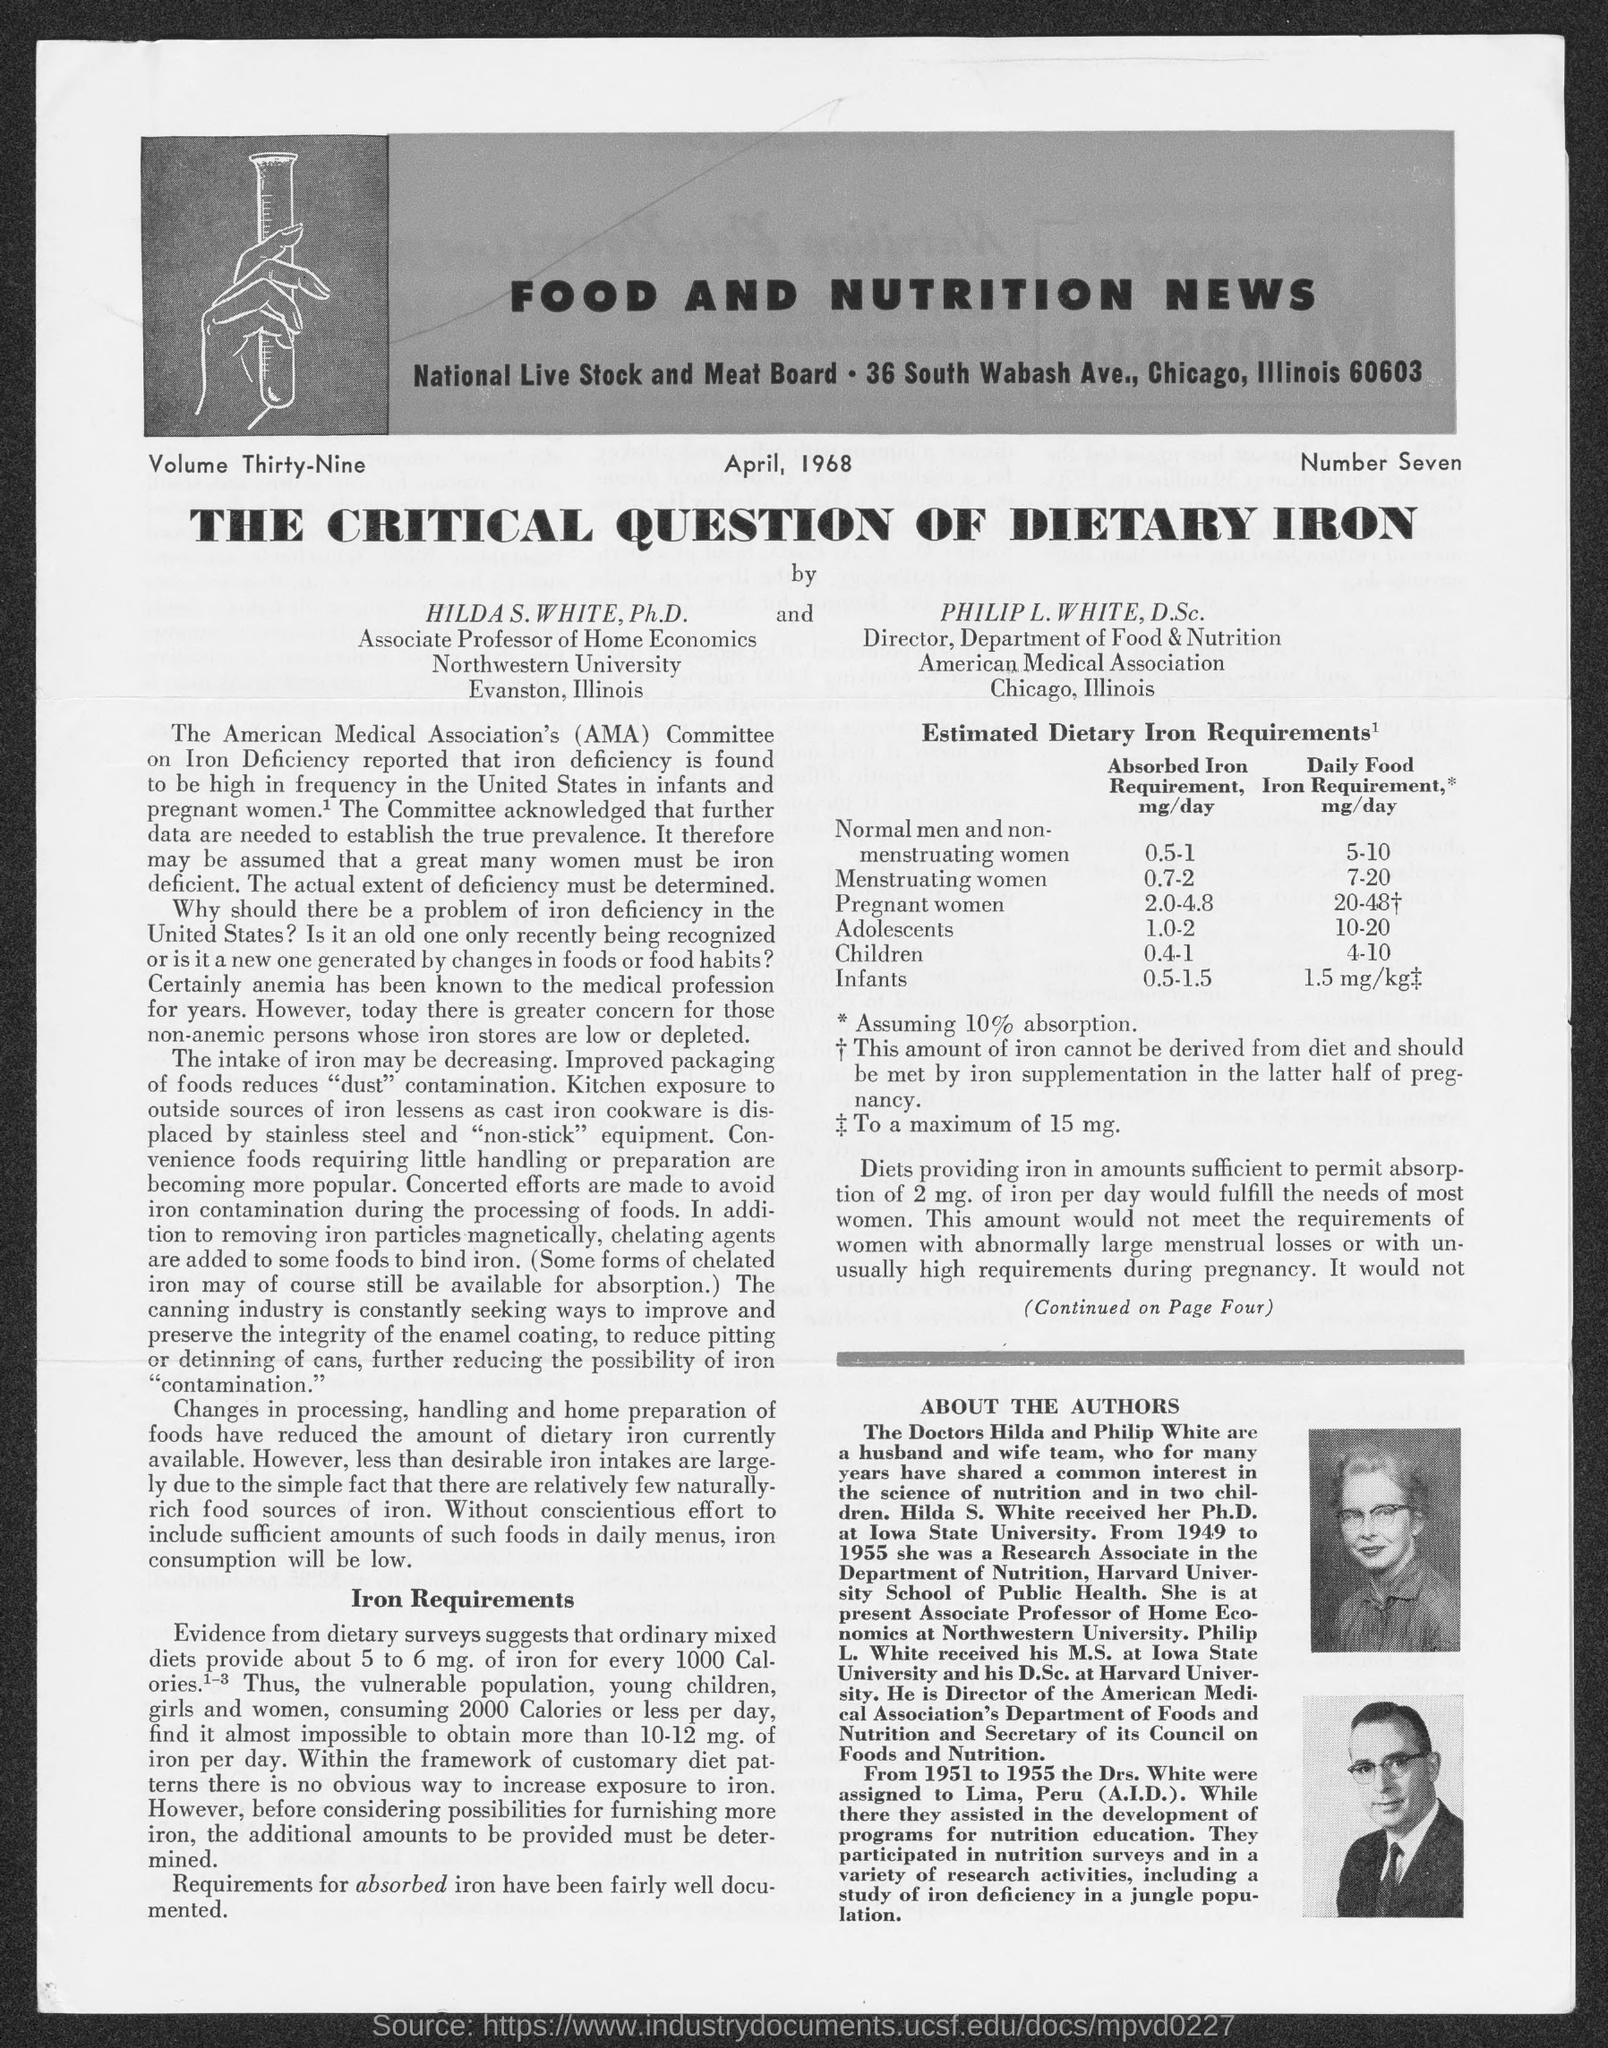What is the name of the news?
Your answer should be compact. Food and Nutrition News. What is the CRITICAL QUESTION about?
Your answer should be compact. DIETARY  IRON. 